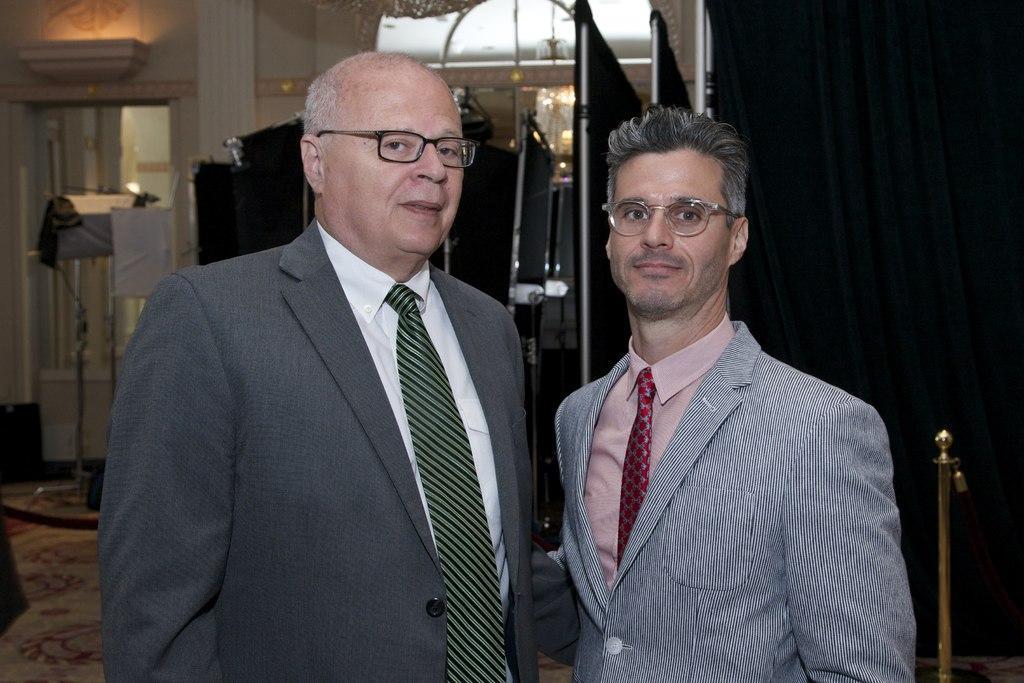Please provide a concise description of this image. In this image, we can see people standing and wearing coats and ties and are wearing glasses. In the background, there are stands and we can see a curtain, lights and some other objects. At the bottom, there is a floor. 